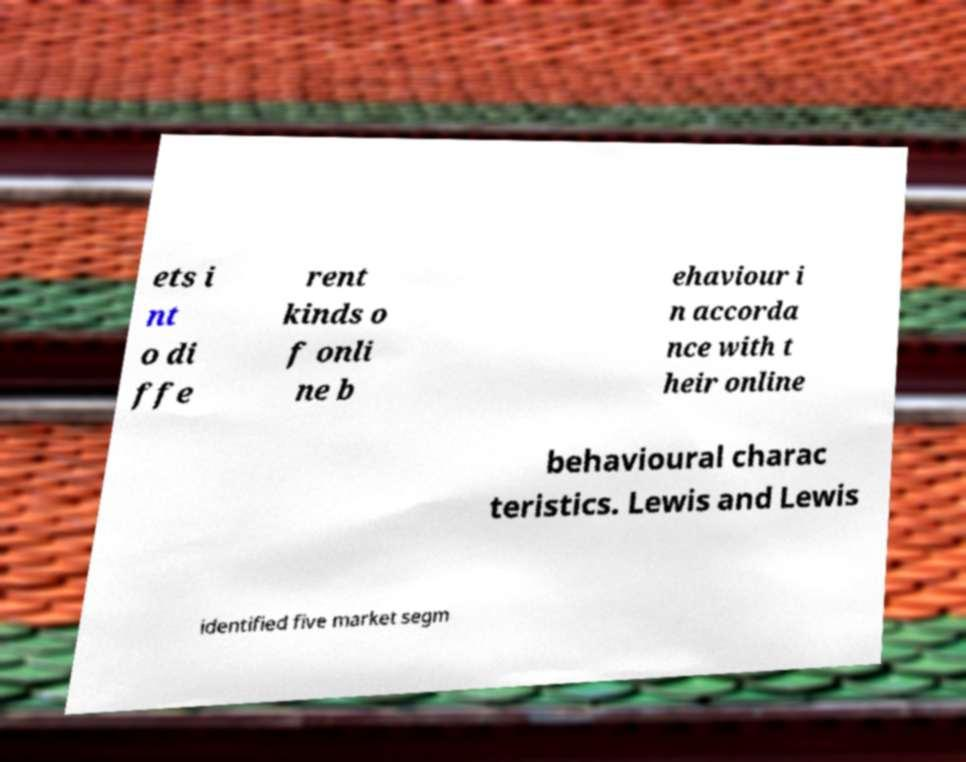Could you extract and type out the text from this image? ets i nt o di ffe rent kinds o f onli ne b ehaviour i n accorda nce with t heir online behavioural charac teristics. Lewis and Lewis identified five market segm 